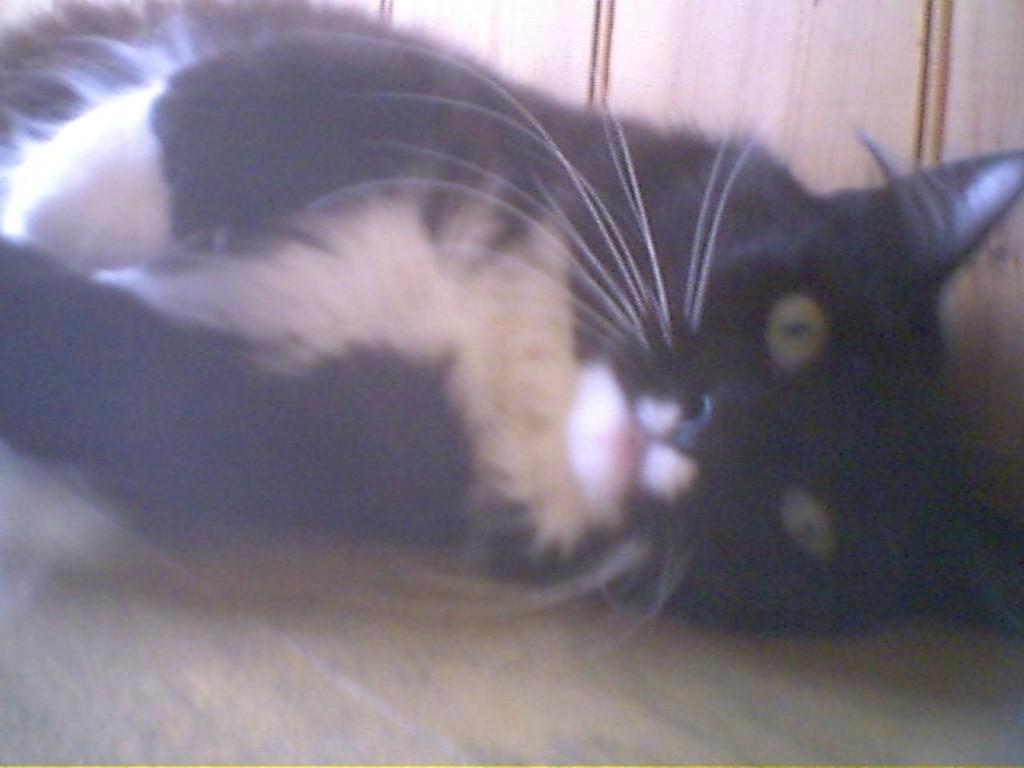Please provide a concise description of this image. In the center of the image there is a cat. At the bottom of the image there is floor. 